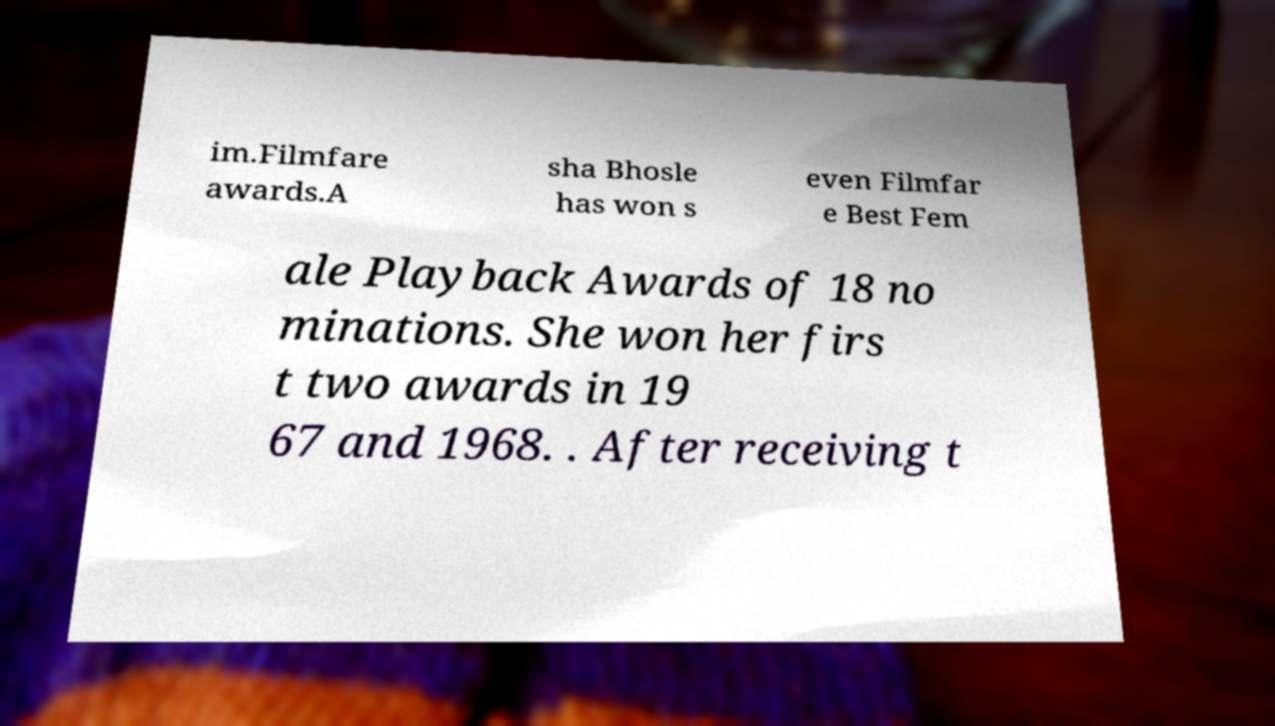Can you accurately transcribe the text from the provided image for me? im.Filmfare awards.A sha Bhosle has won s even Filmfar e Best Fem ale Playback Awards of 18 no minations. She won her firs t two awards in 19 67 and 1968. . After receiving t 